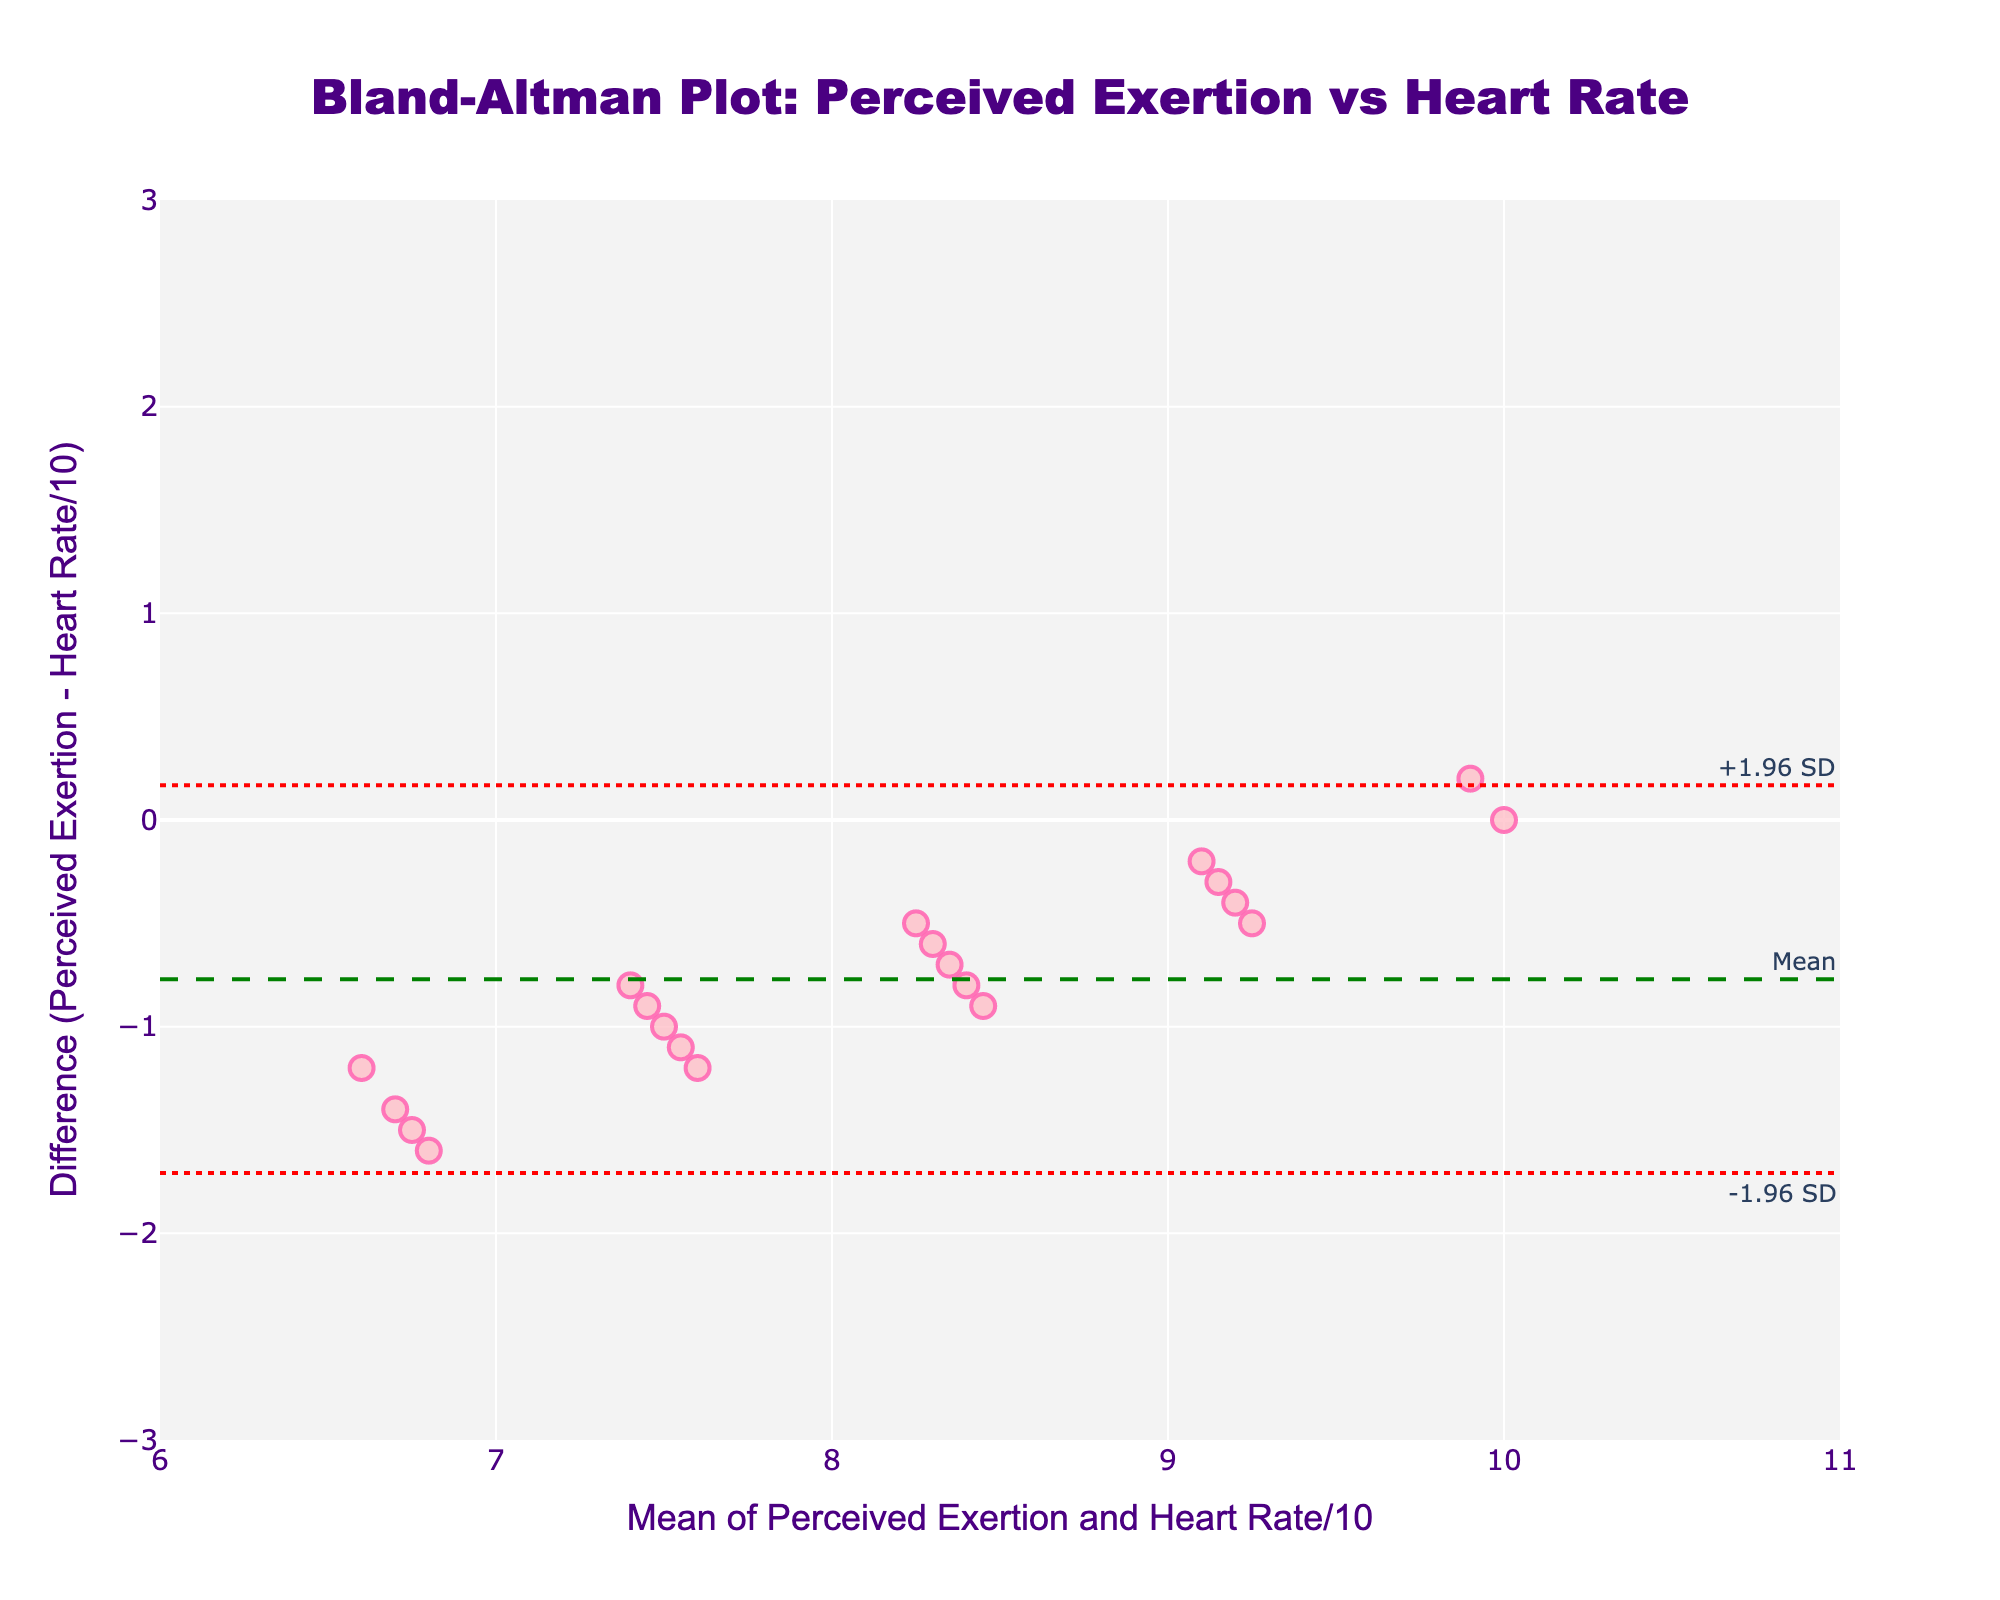What's the title of the plot? The title of the plot is typically found at the top of the figure. In this case, the title is "Bland-Altman Plot: Perceived Exertion vs Heart Rate".
Answer: Bland-Altman Plot: Perceived Exertion vs Heart Rate What's on the X-axis of the plot? The X-axis label is usually found below the horizontal axis. It reads "Mean of Perceived Exertion and Heart Rate/10".
Answer: Mean of Perceived Exertion and Heart Rate/10 What's the mean difference in the plot? The mean difference is represented by the dashed green line. This line is annotated with the text "Mean".
Answer: 0.02 What are the limits of agreement in the plot? The limits of agreement are represented by the dot lines, which are annotated with "+1.96 SD" and "-1.96 SD" at the corresponding y-values.
Answer: +1.96 SD: 1.88, -1.96 SD: -1.84 What's the range of the Y-axis? The range of the Y-axis is visually marked from the bottom to the top of the plot area. According to the axis labels, it ranges from -3 to 3.
Answer: -3 to 3 Where is the densest cluster of data points located on the plot? To identify the densest cluster, observe the plot and note the region where data points are most concentrated. Here, it appears around the mean value of approximately 7-9 on the X-axis.
Answer: Around 7-9 on the X-axis What are the two operations used to calculate the data points on the Y-axis? The first operation is the scaling of the heart rate by dividing by 10, and the second is subtracting this scaled heart rate from the perceived exertion.
Answer: Scaling and subtraction How well do the perceived exertion ratings agree with heart rate measurements? Agreement can be evaluated by examining the mean difference and how data points are distributed relative to the limits of agreement. Most data points fall within the limits, indicating good agreement.
Answer: Good agreement Are any data points outside the limits of agreement? To determine this, observe whether any data points fall outside the dotted red lines representing the limits of agreement. If all are within, none are outside.
Answer: No What does it mean if a data point is below the lower limit of agreement? A data point below the lower limit indicates that the perceived exertion rating is significantly lower than expected compared to the heart rate measurement.
Answer: Perceived exertion is much lower 